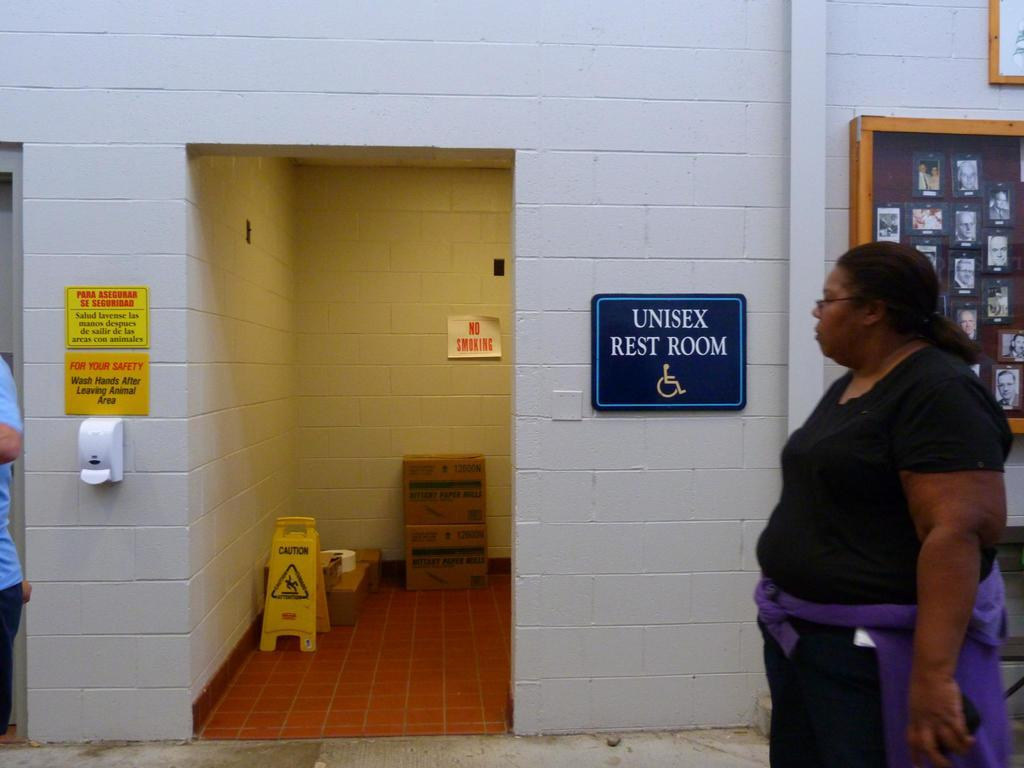Who or what is on the right side of the image? There is a person on the right side of the image. What objects in the image might indicate names or labels? There are name plates in the image. What type of sign is present in the image? There is a caution board in the image. What type of rock can be seen in the image? There is no rock present in the image. What time of day is depicted in the image? The time of day cannot be determined from the image. 